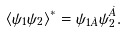<formula> <loc_0><loc_0><loc_500><loc_500>\langle \psi _ { 1 } \psi _ { 2 } \rangle ^ { * } = \psi _ { 1 \dot { A } } \psi ^ { \dot { A } } _ { 2 } .</formula> 